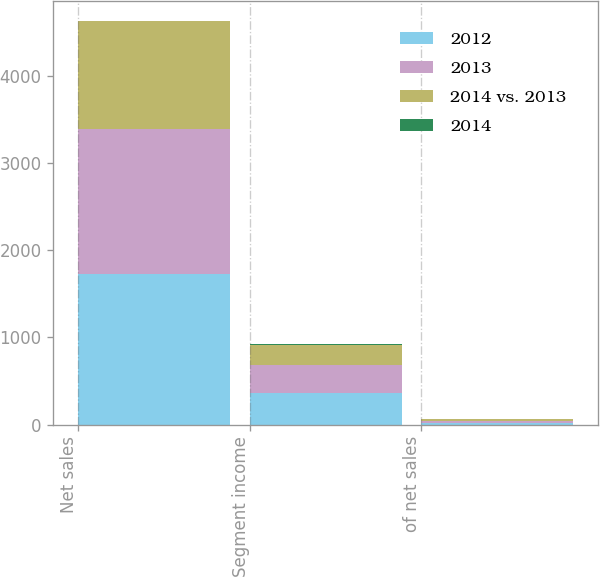Convert chart. <chart><loc_0><loc_0><loc_500><loc_500><stacked_bar_chart><ecel><fcel>Net sales<fcel>Segment income<fcel>of net sales<nl><fcel>2012<fcel>1728.1<fcel>358.8<fcel>20.8<nl><fcel>2013<fcel>1663.4<fcel>322.4<fcel>19.4<nl><fcel>2014 vs. 2013<fcel>1236.4<fcel>232.1<fcel>18.8<nl><fcel>2014<fcel>3.9<fcel>11.3<fcel>1.4<nl></chart> 